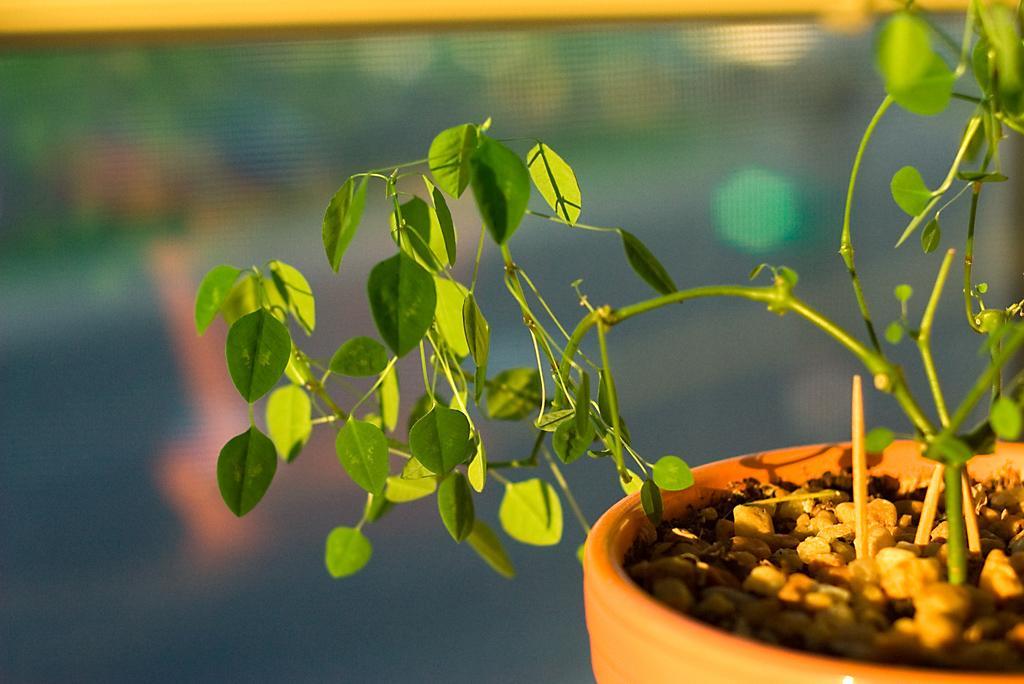In one or two sentences, can you explain what this image depicts? In this image I can see the plant in green color and I can also see the pot in brown color and I can see the blurred background. 